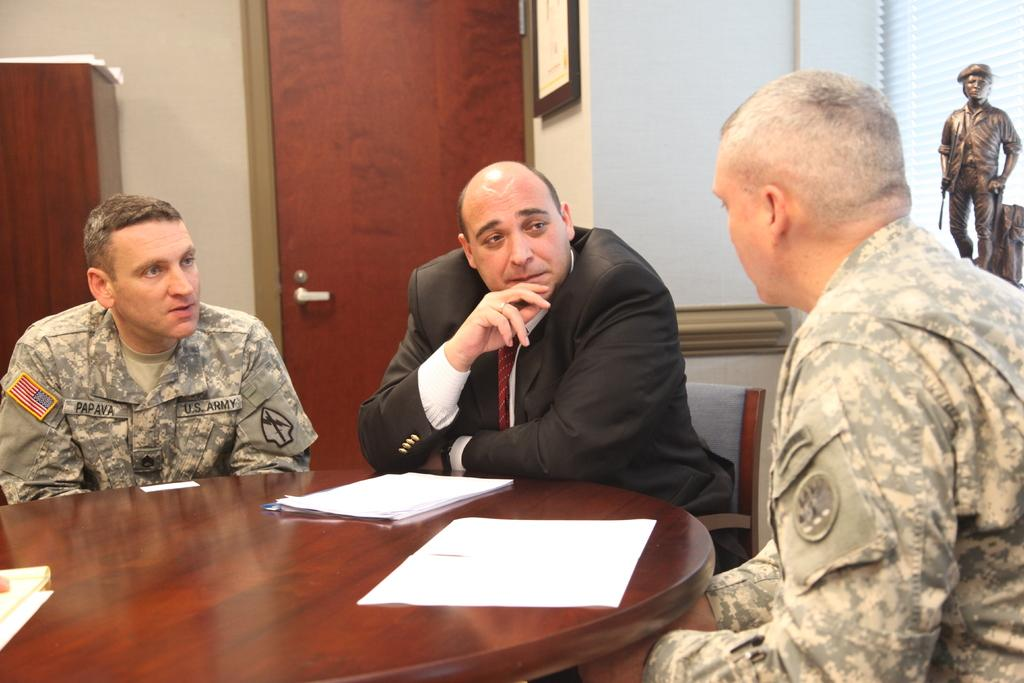How many people are in the image? There are people in the image, but the exact number is not specified. What is one architectural feature visible in the image? There is a door in the image. What type of decorative item can be seen in the image? There is a photo frame in the image. What type of artwork is present in the image? There is a sculpture in the image. What type of furniture is visible in the image? There are chairs in the image. What type of surface is present in the image for placing objects? There is a table in the image. What type of items can be seen on the table? There are papers on the table. What type of zinc object is present in the image? There is no mention of zinc or any zinc objects in the image. Is there a camp visible in the image? There is no mention of a camp or any camp-related objects in the image. 